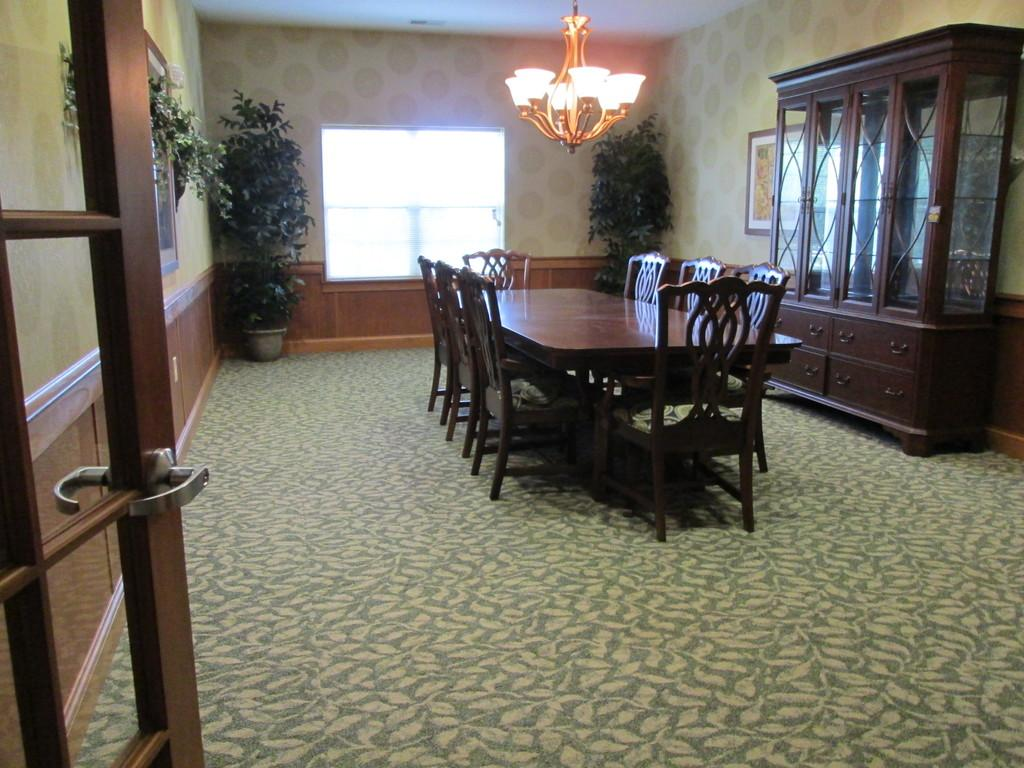What type of furniture is present in the image? There is a table and chairs in the image. Can you describe the wooden structure on the right side of the image? There is a wooden shelf on the right side of the image. What can be seen in the background of the image? There is a window in the background of the image. What type of music is being played in the class during the meeting in the image? There is no indication of music, class, or meeting in the image. The image only shows a table, chairs, a wooden shelf, and a window. 